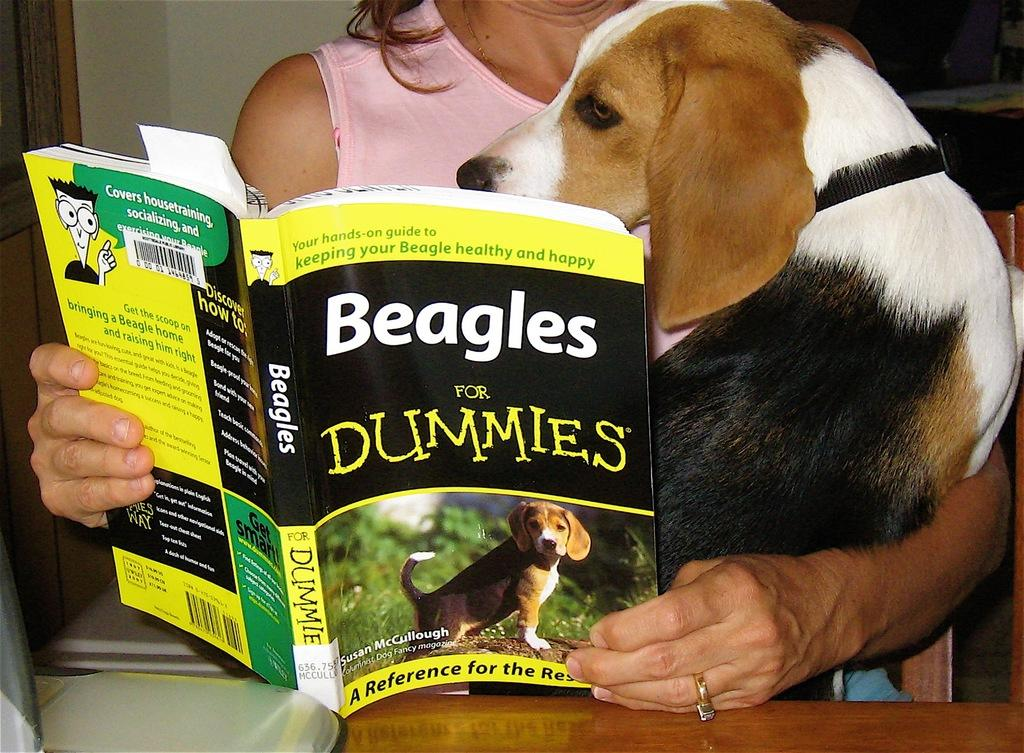Who is present in the image? There is a woman in the image. What is the woman holding in her hands? The woman is holding a dog and a book. What can be seen in the background of the image? There is a door and a wall in the background of the image. What song is the woman singing in the image? There is no indication in the image that the woman is singing a song, so it cannot be determined from the picture. 